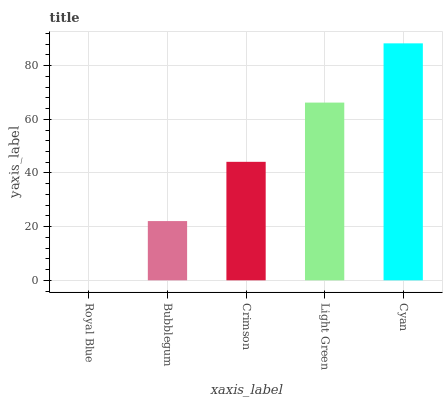Is Royal Blue the minimum?
Answer yes or no. Yes. Is Cyan the maximum?
Answer yes or no. Yes. Is Bubblegum the minimum?
Answer yes or no. No. Is Bubblegum the maximum?
Answer yes or no. No. Is Bubblegum greater than Royal Blue?
Answer yes or no. Yes. Is Royal Blue less than Bubblegum?
Answer yes or no. Yes. Is Royal Blue greater than Bubblegum?
Answer yes or no. No. Is Bubblegum less than Royal Blue?
Answer yes or no. No. Is Crimson the high median?
Answer yes or no. Yes. Is Crimson the low median?
Answer yes or no. Yes. Is Royal Blue the high median?
Answer yes or no. No. Is Royal Blue the low median?
Answer yes or no. No. 